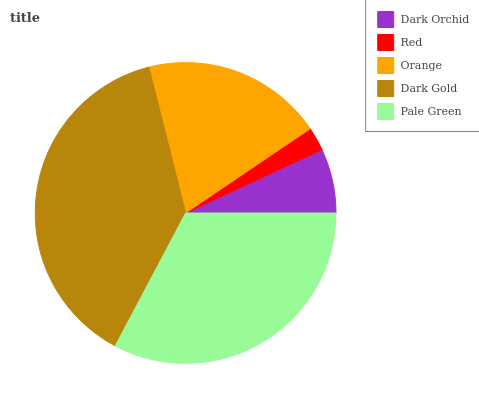Is Red the minimum?
Answer yes or no. Yes. Is Dark Gold the maximum?
Answer yes or no. Yes. Is Orange the minimum?
Answer yes or no. No. Is Orange the maximum?
Answer yes or no. No. Is Orange greater than Red?
Answer yes or no. Yes. Is Red less than Orange?
Answer yes or no. Yes. Is Red greater than Orange?
Answer yes or no. No. Is Orange less than Red?
Answer yes or no. No. Is Orange the high median?
Answer yes or no. Yes. Is Orange the low median?
Answer yes or no. Yes. Is Dark Gold the high median?
Answer yes or no. No. Is Red the low median?
Answer yes or no. No. 